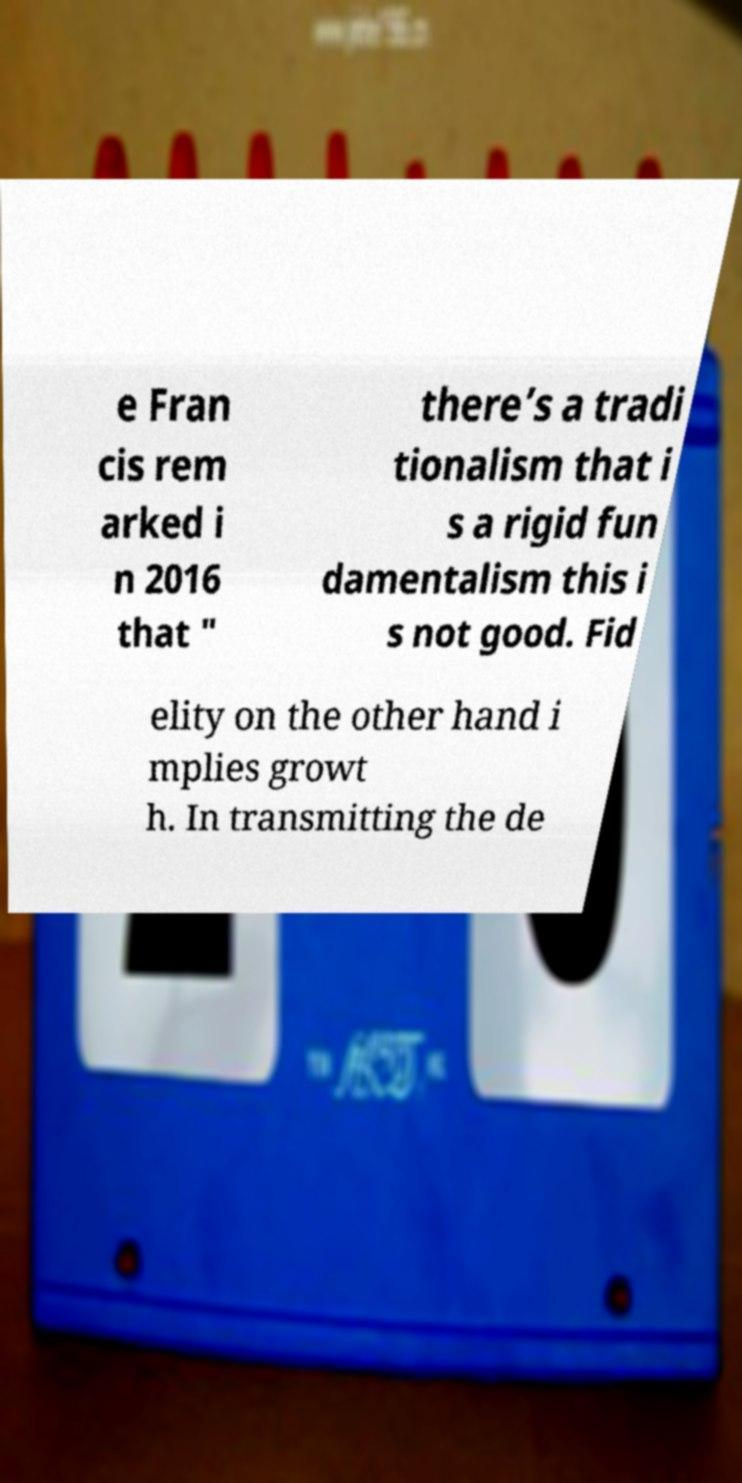Could you assist in decoding the text presented in this image and type it out clearly? e Fran cis rem arked i n 2016 that " there’s a tradi tionalism that i s a rigid fun damentalism this i s not good. Fid elity on the other hand i mplies growt h. In transmitting the de 